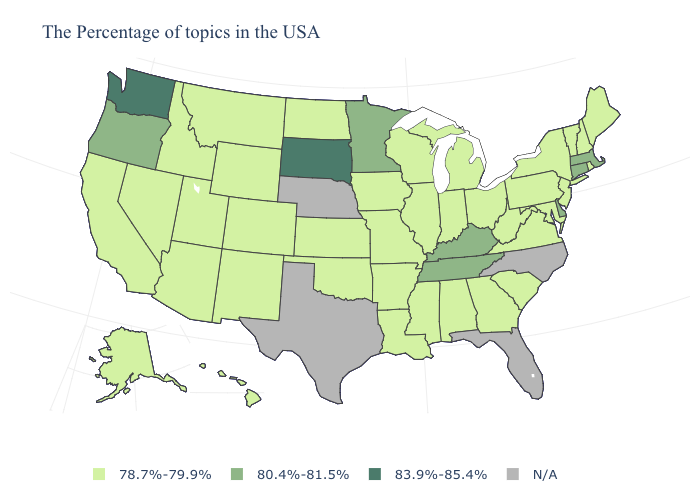What is the lowest value in the MidWest?
Short answer required. 78.7%-79.9%. Name the states that have a value in the range N/A?
Be succinct. North Carolina, Florida, Nebraska, Texas. What is the highest value in states that border Maine?
Be succinct. 78.7%-79.9%. Which states have the lowest value in the South?
Answer briefly. Maryland, Virginia, South Carolina, West Virginia, Georgia, Alabama, Mississippi, Louisiana, Arkansas, Oklahoma. What is the highest value in the West ?
Short answer required. 83.9%-85.4%. Among the states that border Texas , which have the lowest value?
Concise answer only. Louisiana, Arkansas, Oklahoma, New Mexico. Does New Jersey have the lowest value in the USA?
Keep it brief. Yes. Among the states that border Connecticut , does Rhode Island have the lowest value?
Keep it brief. Yes. Does the first symbol in the legend represent the smallest category?
Keep it brief. Yes. Name the states that have a value in the range 80.4%-81.5%?
Concise answer only. Massachusetts, Connecticut, Delaware, Kentucky, Tennessee, Minnesota, Oregon. Which states have the lowest value in the MidWest?
Concise answer only. Ohio, Michigan, Indiana, Wisconsin, Illinois, Missouri, Iowa, Kansas, North Dakota. What is the value of Oregon?
Keep it brief. 80.4%-81.5%. Among the states that border West Virginia , does Kentucky have the highest value?
Short answer required. Yes. What is the lowest value in the USA?
Write a very short answer. 78.7%-79.9%. What is the value of California?
Quick response, please. 78.7%-79.9%. 